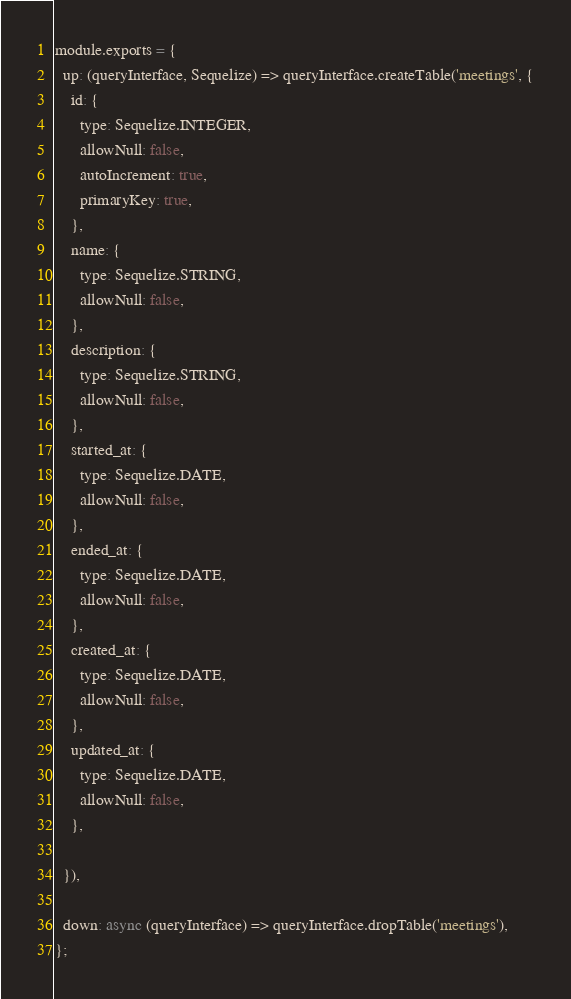<code> <loc_0><loc_0><loc_500><loc_500><_JavaScript_>module.exports = {
  up: (queryInterface, Sequelize) => queryInterface.createTable('meetings', {
    id: {
      type: Sequelize.INTEGER,
      allowNull: false,
      autoIncrement: true,
      primaryKey: true,
    },
    name: {
      type: Sequelize.STRING,
      allowNull: false,
    },
    description: {
      type: Sequelize.STRING,
      allowNull: false,
    },
    started_at: {
      type: Sequelize.DATE,
      allowNull: false,
    },
    ended_at: {
      type: Sequelize.DATE,
      allowNull: false,
    },
    created_at: {
      type: Sequelize.DATE,
      allowNull: false,
    },
    updated_at: {
      type: Sequelize.DATE,
      allowNull: false,
    },

  }),

  down: async (queryInterface) => queryInterface.dropTable('meetings'),
};
</code> 